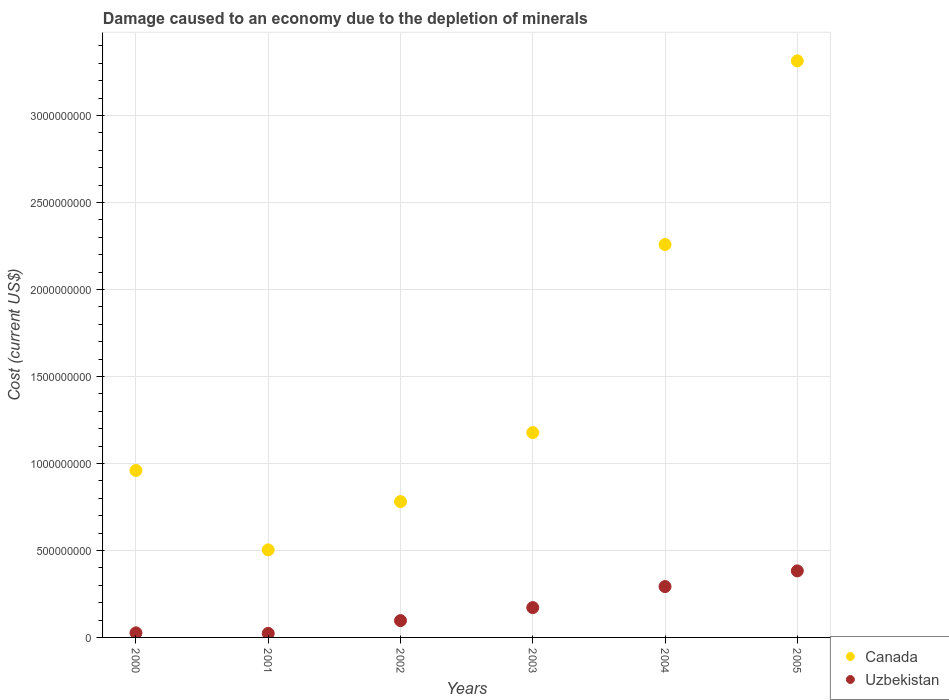How many different coloured dotlines are there?
Give a very brief answer. 2. What is the cost of damage caused due to the depletion of minerals in Canada in 2003?
Ensure brevity in your answer.  1.18e+09. Across all years, what is the maximum cost of damage caused due to the depletion of minerals in Canada?
Your response must be concise. 3.31e+09. Across all years, what is the minimum cost of damage caused due to the depletion of minerals in Canada?
Keep it short and to the point. 5.03e+08. In which year was the cost of damage caused due to the depletion of minerals in Canada maximum?
Keep it short and to the point. 2005. In which year was the cost of damage caused due to the depletion of minerals in Uzbekistan minimum?
Your response must be concise. 2001. What is the total cost of damage caused due to the depletion of minerals in Uzbekistan in the graph?
Give a very brief answer. 9.92e+08. What is the difference between the cost of damage caused due to the depletion of minerals in Canada in 2003 and that in 2005?
Provide a succinct answer. -2.14e+09. What is the difference between the cost of damage caused due to the depletion of minerals in Canada in 2003 and the cost of damage caused due to the depletion of minerals in Uzbekistan in 2001?
Provide a succinct answer. 1.15e+09. What is the average cost of damage caused due to the depletion of minerals in Canada per year?
Provide a short and direct response. 1.50e+09. In the year 2000, what is the difference between the cost of damage caused due to the depletion of minerals in Uzbekistan and cost of damage caused due to the depletion of minerals in Canada?
Offer a very short reply. -9.33e+08. In how many years, is the cost of damage caused due to the depletion of minerals in Uzbekistan greater than 300000000 US$?
Offer a terse response. 1. What is the ratio of the cost of damage caused due to the depletion of minerals in Uzbekistan in 2002 to that in 2005?
Offer a very short reply. 0.25. What is the difference between the highest and the second highest cost of damage caused due to the depletion of minerals in Canada?
Your answer should be compact. 1.06e+09. What is the difference between the highest and the lowest cost of damage caused due to the depletion of minerals in Uzbekistan?
Your response must be concise. 3.59e+08. Is the sum of the cost of damage caused due to the depletion of minerals in Uzbekistan in 2003 and 2005 greater than the maximum cost of damage caused due to the depletion of minerals in Canada across all years?
Give a very brief answer. No. Does the cost of damage caused due to the depletion of minerals in Uzbekistan monotonically increase over the years?
Offer a terse response. No. Is the cost of damage caused due to the depletion of minerals in Uzbekistan strictly greater than the cost of damage caused due to the depletion of minerals in Canada over the years?
Provide a succinct answer. No. Is the cost of damage caused due to the depletion of minerals in Canada strictly less than the cost of damage caused due to the depletion of minerals in Uzbekistan over the years?
Your response must be concise. No. What is the difference between two consecutive major ticks on the Y-axis?
Your answer should be compact. 5.00e+08. Are the values on the major ticks of Y-axis written in scientific E-notation?
Give a very brief answer. No. Does the graph contain grids?
Offer a terse response. Yes. Where does the legend appear in the graph?
Offer a very short reply. Bottom right. How many legend labels are there?
Make the answer very short. 2. What is the title of the graph?
Make the answer very short. Damage caused to an economy due to the depletion of minerals. Does "New Caledonia" appear as one of the legend labels in the graph?
Your response must be concise. No. What is the label or title of the X-axis?
Provide a short and direct response. Years. What is the label or title of the Y-axis?
Offer a very short reply. Cost (current US$). What is the Cost (current US$) in Canada in 2000?
Your answer should be compact. 9.60e+08. What is the Cost (current US$) of Uzbekistan in 2000?
Ensure brevity in your answer.  2.63e+07. What is the Cost (current US$) of Canada in 2001?
Give a very brief answer. 5.03e+08. What is the Cost (current US$) in Uzbekistan in 2001?
Your response must be concise. 2.32e+07. What is the Cost (current US$) of Canada in 2002?
Offer a very short reply. 7.80e+08. What is the Cost (current US$) in Uzbekistan in 2002?
Ensure brevity in your answer.  9.67e+07. What is the Cost (current US$) of Canada in 2003?
Your answer should be compact. 1.18e+09. What is the Cost (current US$) of Uzbekistan in 2003?
Give a very brief answer. 1.71e+08. What is the Cost (current US$) of Canada in 2004?
Offer a terse response. 2.26e+09. What is the Cost (current US$) of Uzbekistan in 2004?
Offer a very short reply. 2.92e+08. What is the Cost (current US$) in Canada in 2005?
Provide a succinct answer. 3.31e+09. What is the Cost (current US$) of Uzbekistan in 2005?
Provide a succinct answer. 3.82e+08. Across all years, what is the maximum Cost (current US$) in Canada?
Provide a short and direct response. 3.31e+09. Across all years, what is the maximum Cost (current US$) in Uzbekistan?
Provide a short and direct response. 3.82e+08. Across all years, what is the minimum Cost (current US$) of Canada?
Your answer should be compact. 5.03e+08. Across all years, what is the minimum Cost (current US$) of Uzbekistan?
Give a very brief answer. 2.32e+07. What is the total Cost (current US$) in Canada in the graph?
Provide a short and direct response. 8.99e+09. What is the total Cost (current US$) in Uzbekistan in the graph?
Provide a succinct answer. 9.92e+08. What is the difference between the Cost (current US$) of Canada in 2000 and that in 2001?
Offer a terse response. 4.56e+08. What is the difference between the Cost (current US$) in Uzbekistan in 2000 and that in 2001?
Provide a short and direct response. 3.15e+06. What is the difference between the Cost (current US$) of Canada in 2000 and that in 2002?
Your response must be concise. 1.79e+08. What is the difference between the Cost (current US$) of Uzbekistan in 2000 and that in 2002?
Your response must be concise. -7.03e+07. What is the difference between the Cost (current US$) in Canada in 2000 and that in 2003?
Offer a very short reply. -2.18e+08. What is the difference between the Cost (current US$) in Uzbekistan in 2000 and that in 2003?
Offer a very short reply. -1.45e+08. What is the difference between the Cost (current US$) in Canada in 2000 and that in 2004?
Provide a succinct answer. -1.30e+09. What is the difference between the Cost (current US$) in Uzbekistan in 2000 and that in 2004?
Your response must be concise. -2.66e+08. What is the difference between the Cost (current US$) of Canada in 2000 and that in 2005?
Ensure brevity in your answer.  -2.35e+09. What is the difference between the Cost (current US$) of Uzbekistan in 2000 and that in 2005?
Ensure brevity in your answer.  -3.56e+08. What is the difference between the Cost (current US$) in Canada in 2001 and that in 2002?
Your answer should be compact. -2.77e+08. What is the difference between the Cost (current US$) of Uzbekistan in 2001 and that in 2002?
Offer a terse response. -7.35e+07. What is the difference between the Cost (current US$) in Canada in 2001 and that in 2003?
Your answer should be compact. -6.74e+08. What is the difference between the Cost (current US$) of Uzbekistan in 2001 and that in 2003?
Your answer should be compact. -1.48e+08. What is the difference between the Cost (current US$) in Canada in 2001 and that in 2004?
Provide a succinct answer. -1.75e+09. What is the difference between the Cost (current US$) in Uzbekistan in 2001 and that in 2004?
Provide a short and direct response. -2.69e+08. What is the difference between the Cost (current US$) of Canada in 2001 and that in 2005?
Your answer should be very brief. -2.81e+09. What is the difference between the Cost (current US$) in Uzbekistan in 2001 and that in 2005?
Ensure brevity in your answer.  -3.59e+08. What is the difference between the Cost (current US$) of Canada in 2002 and that in 2003?
Your answer should be compact. -3.97e+08. What is the difference between the Cost (current US$) of Uzbekistan in 2002 and that in 2003?
Keep it short and to the point. -7.48e+07. What is the difference between the Cost (current US$) in Canada in 2002 and that in 2004?
Offer a very short reply. -1.48e+09. What is the difference between the Cost (current US$) of Uzbekistan in 2002 and that in 2004?
Your answer should be very brief. -1.96e+08. What is the difference between the Cost (current US$) of Canada in 2002 and that in 2005?
Your answer should be very brief. -2.53e+09. What is the difference between the Cost (current US$) in Uzbekistan in 2002 and that in 2005?
Provide a succinct answer. -2.86e+08. What is the difference between the Cost (current US$) in Canada in 2003 and that in 2004?
Offer a very short reply. -1.08e+09. What is the difference between the Cost (current US$) of Uzbekistan in 2003 and that in 2004?
Provide a short and direct response. -1.21e+08. What is the difference between the Cost (current US$) of Canada in 2003 and that in 2005?
Keep it short and to the point. -2.14e+09. What is the difference between the Cost (current US$) of Uzbekistan in 2003 and that in 2005?
Offer a very short reply. -2.11e+08. What is the difference between the Cost (current US$) in Canada in 2004 and that in 2005?
Your answer should be compact. -1.06e+09. What is the difference between the Cost (current US$) in Uzbekistan in 2004 and that in 2005?
Offer a very short reply. -9.00e+07. What is the difference between the Cost (current US$) in Canada in 2000 and the Cost (current US$) in Uzbekistan in 2001?
Give a very brief answer. 9.36e+08. What is the difference between the Cost (current US$) of Canada in 2000 and the Cost (current US$) of Uzbekistan in 2002?
Provide a short and direct response. 8.63e+08. What is the difference between the Cost (current US$) of Canada in 2000 and the Cost (current US$) of Uzbekistan in 2003?
Offer a terse response. 7.88e+08. What is the difference between the Cost (current US$) in Canada in 2000 and the Cost (current US$) in Uzbekistan in 2004?
Provide a short and direct response. 6.67e+08. What is the difference between the Cost (current US$) of Canada in 2000 and the Cost (current US$) of Uzbekistan in 2005?
Keep it short and to the point. 5.77e+08. What is the difference between the Cost (current US$) of Canada in 2001 and the Cost (current US$) of Uzbekistan in 2002?
Provide a succinct answer. 4.07e+08. What is the difference between the Cost (current US$) of Canada in 2001 and the Cost (current US$) of Uzbekistan in 2003?
Provide a short and direct response. 3.32e+08. What is the difference between the Cost (current US$) of Canada in 2001 and the Cost (current US$) of Uzbekistan in 2004?
Ensure brevity in your answer.  2.11e+08. What is the difference between the Cost (current US$) of Canada in 2001 and the Cost (current US$) of Uzbekistan in 2005?
Make the answer very short. 1.21e+08. What is the difference between the Cost (current US$) of Canada in 2002 and the Cost (current US$) of Uzbekistan in 2003?
Keep it short and to the point. 6.09e+08. What is the difference between the Cost (current US$) of Canada in 2002 and the Cost (current US$) of Uzbekistan in 2004?
Offer a terse response. 4.88e+08. What is the difference between the Cost (current US$) of Canada in 2002 and the Cost (current US$) of Uzbekistan in 2005?
Give a very brief answer. 3.98e+08. What is the difference between the Cost (current US$) of Canada in 2003 and the Cost (current US$) of Uzbekistan in 2004?
Your answer should be very brief. 8.85e+08. What is the difference between the Cost (current US$) in Canada in 2003 and the Cost (current US$) in Uzbekistan in 2005?
Your answer should be compact. 7.95e+08. What is the difference between the Cost (current US$) of Canada in 2004 and the Cost (current US$) of Uzbekistan in 2005?
Offer a terse response. 1.88e+09. What is the average Cost (current US$) in Canada per year?
Offer a terse response. 1.50e+09. What is the average Cost (current US$) of Uzbekistan per year?
Your response must be concise. 1.65e+08. In the year 2000, what is the difference between the Cost (current US$) of Canada and Cost (current US$) of Uzbekistan?
Keep it short and to the point. 9.33e+08. In the year 2001, what is the difference between the Cost (current US$) in Canada and Cost (current US$) in Uzbekistan?
Your answer should be compact. 4.80e+08. In the year 2002, what is the difference between the Cost (current US$) in Canada and Cost (current US$) in Uzbekistan?
Ensure brevity in your answer.  6.84e+08. In the year 2003, what is the difference between the Cost (current US$) in Canada and Cost (current US$) in Uzbekistan?
Provide a short and direct response. 1.01e+09. In the year 2004, what is the difference between the Cost (current US$) of Canada and Cost (current US$) of Uzbekistan?
Ensure brevity in your answer.  1.97e+09. In the year 2005, what is the difference between the Cost (current US$) in Canada and Cost (current US$) in Uzbekistan?
Your response must be concise. 2.93e+09. What is the ratio of the Cost (current US$) in Canada in 2000 to that in 2001?
Keep it short and to the point. 1.91. What is the ratio of the Cost (current US$) in Uzbekistan in 2000 to that in 2001?
Give a very brief answer. 1.14. What is the ratio of the Cost (current US$) in Canada in 2000 to that in 2002?
Make the answer very short. 1.23. What is the ratio of the Cost (current US$) in Uzbekistan in 2000 to that in 2002?
Make the answer very short. 0.27. What is the ratio of the Cost (current US$) in Canada in 2000 to that in 2003?
Offer a very short reply. 0.82. What is the ratio of the Cost (current US$) in Uzbekistan in 2000 to that in 2003?
Offer a terse response. 0.15. What is the ratio of the Cost (current US$) in Canada in 2000 to that in 2004?
Provide a short and direct response. 0.42. What is the ratio of the Cost (current US$) of Uzbekistan in 2000 to that in 2004?
Keep it short and to the point. 0.09. What is the ratio of the Cost (current US$) in Canada in 2000 to that in 2005?
Provide a succinct answer. 0.29. What is the ratio of the Cost (current US$) of Uzbekistan in 2000 to that in 2005?
Your response must be concise. 0.07. What is the ratio of the Cost (current US$) in Canada in 2001 to that in 2002?
Provide a succinct answer. 0.64. What is the ratio of the Cost (current US$) in Uzbekistan in 2001 to that in 2002?
Provide a short and direct response. 0.24. What is the ratio of the Cost (current US$) of Canada in 2001 to that in 2003?
Your answer should be compact. 0.43. What is the ratio of the Cost (current US$) of Uzbekistan in 2001 to that in 2003?
Keep it short and to the point. 0.14. What is the ratio of the Cost (current US$) of Canada in 2001 to that in 2004?
Your answer should be very brief. 0.22. What is the ratio of the Cost (current US$) in Uzbekistan in 2001 to that in 2004?
Provide a succinct answer. 0.08. What is the ratio of the Cost (current US$) of Canada in 2001 to that in 2005?
Give a very brief answer. 0.15. What is the ratio of the Cost (current US$) in Uzbekistan in 2001 to that in 2005?
Keep it short and to the point. 0.06. What is the ratio of the Cost (current US$) in Canada in 2002 to that in 2003?
Ensure brevity in your answer.  0.66. What is the ratio of the Cost (current US$) of Uzbekistan in 2002 to that in 2003?
Keep it short and to the point. 0.56. What is the ratio of the Cost (current US$) in Canada in 2002 to that in 2004?
Make the answer very short. 0.35. What is the ratio of the Cost (current US$) in Uzbekistan in 2002 to that in 2004?
Provide a short and direct response. 0.33. What is the ratio of the Cost (current US$) of Canada in 2002 to that in 2005?
Your answer should be very brief. 0.24. What is the ratio of the Cost (current US$) of Uzbekistan in 2002 to that in 2005?
Give a very brief answer. 0.25. What is the ratio of the Cost (current US$) in Canada in 2003 to that in 2004?
Your answer should be compact. 0.52. What is the ratio of the Cost (current US$) in Uzbekistan in 2003 to that in 2004?
Make the answer very short. 0.59. What is the ratio of the Cost (current US$) in Canada in 2003 to that in 2005?
Provide a short and direct response. 0.36. What is the ratio of the Cost (current US$) of Uzbekistan in 2003 to that in 2005?
Your answer should be very brief. 0.45. What is the ratio of the Cost (current US$) of Canada in 2004 to that in 2005?
Make the answer very short. 0.68. What is the ratio of the Cost (current US$) of Uzbekistan in 2004 to that in 2005?
Offer a terse response. 0.76. What is the difference between the highest and the second highest Cost (current US$) of Canada?
Make the answer very short. 1.06e+09. What is the difference between the highest and the second highest Cost (current US$) in Uzbekistan?
Offer a very short reply. 9.00e+07. What is the difference between the highest and the lowest Cost (current US$) of Canada?
Offer a terse response. 2.81e+09. What is the difference between the highest and the lowest Cost (current US$) of Uzbekistan?
Offer a terse response. 3.59e+08. 